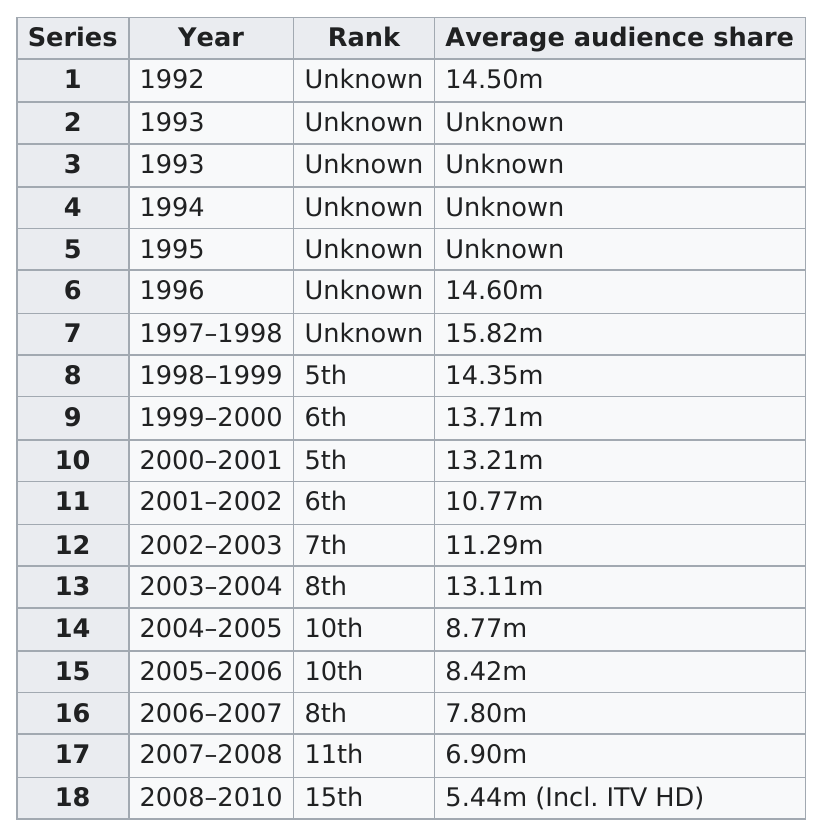Point out several critical features in this image. The Heartbeat series ran for a total of 18 years. Between 2008 and 2010, the ratings for this particular thing received the lowest ranking of all years reviewed. The years 1997-1998 saw the greatest average audience share. 